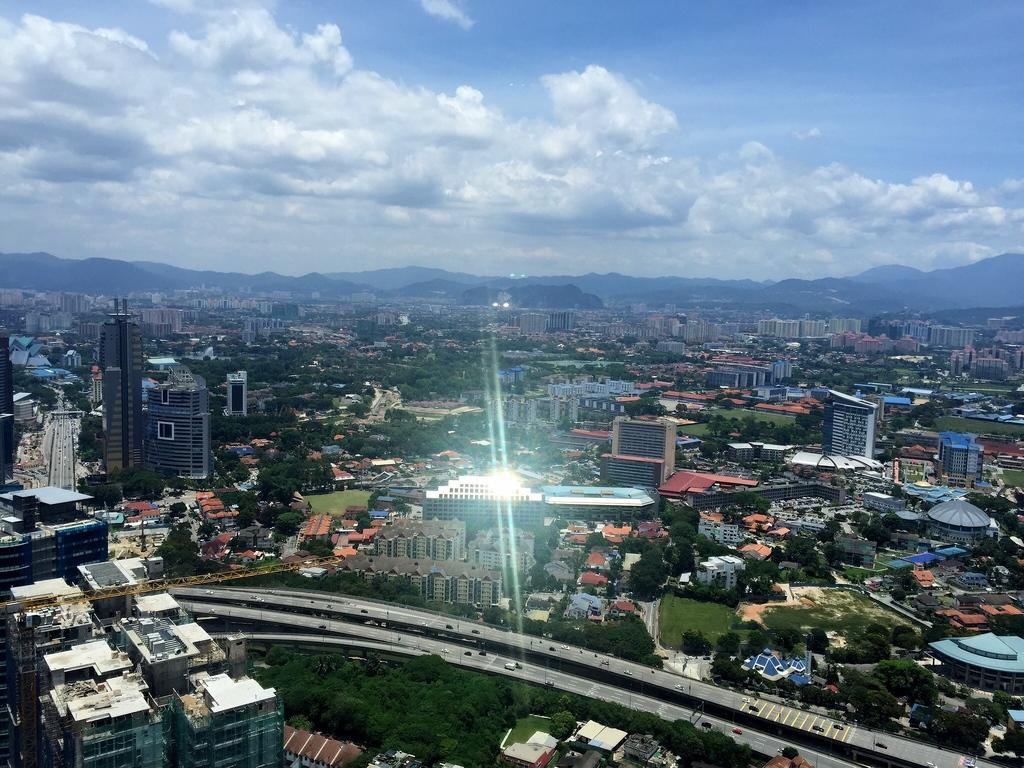What type of structures can be seen in the image? There are buildings in the image. What other natural elements are present in the image? There are trees and mountains in the image. What is happening on the road in the image? Cars are moving on the road in the image. How would you describe the weather in the image? The sky is cloudy in the image. What type of gold can be seen on the cars in the image? There is no gold present on the cars in the image. Are the drivers of the cars in the image required to have insurance? The image does not provide information about the drivers or their insurance status. 